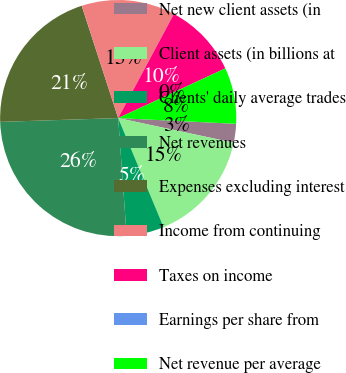Convert chart to OTSL. <chart><loc_0><loc_0><loc_500><loc_500><pie_chart><fcel>Net new client assets (in<fcel>Client assets (in billions at<fcel>Clients' daily average trades<fcel>Net revenues<fcel>Expenses excluding interest<fcel>Income from continuing<fcel>Taxes on income<fcel>Earnings per share from<fcel>Net revenue per average<nl><fcel>2.57%<fcel>15.38%<fcel>5.13%<fcel>25.63%<fcel>20.51%<fcel>12.82%<fcel>10.26%<fcel>0.0%<fcel>7.69%<nl></chart> 